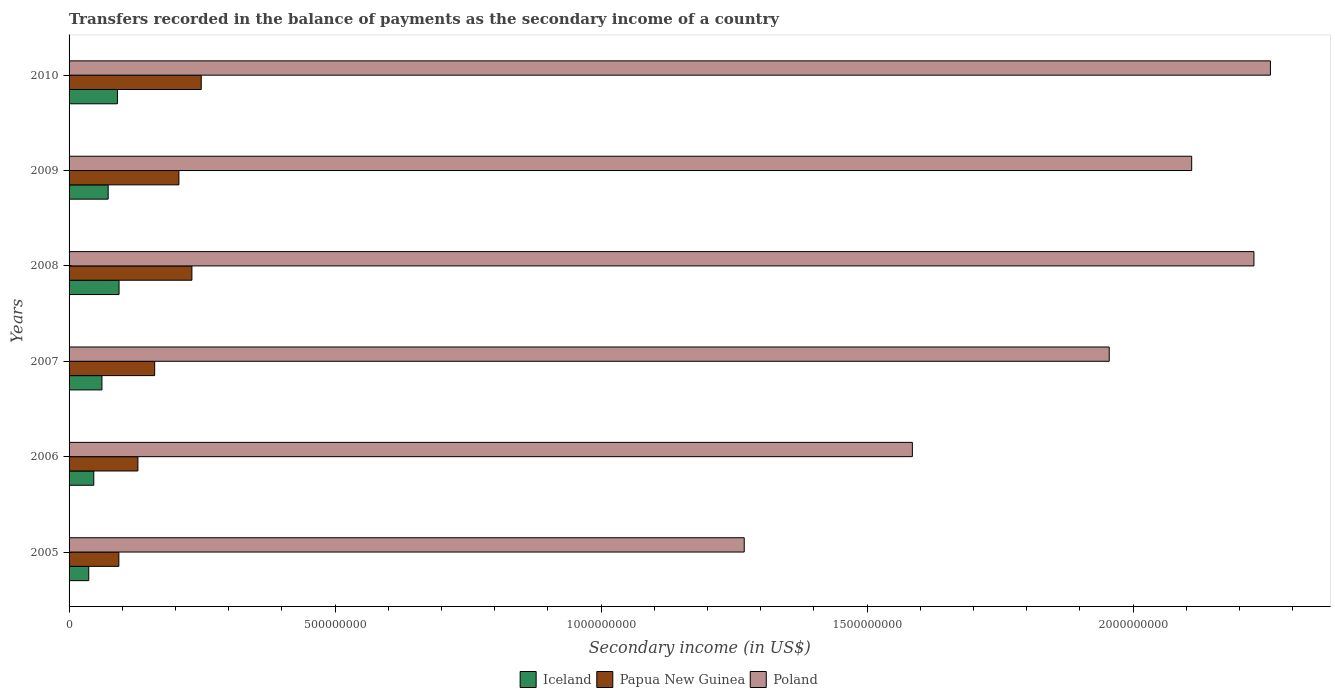How many different coloured bars are there?
Your answer should be compact. 3. How many groups of bars are there?
Provide a short and direct response. 6. Are the number of bars on each tick of the Y-axis equal?
Provide a short and direct response. Yes. How many bars are there on the 4th tick from the top?
Your response must be concise. 3. How many bars are there on the 3rd tick from the bottom?
Your answer should be very brief. 3. What is the label of the 4th group of bars from the top?
Provide a short and direct response. 2007. In how many cases, is the number of bars for a given year not equal to the number of legend labels?
Give a very brief answer. 0. What is the secondary income of in Papua New Guinea in 2010?
Keep it short and to the point. 2.48e+08. Across all years, what is the maximum secondary income of in Poland?
Your answer should be compact. 2.26e+09. Across all years, what is the minimum secondary income of in Poland?
Your response must be concise. 1.27e+09. In which year was the secondary income of in Poland maximum?
Provide a short and direct response. 2010. What is the total secondary income of in Poland in the graph?
Make the answer very short. 1.14e+1. What is the difference between the secondary income of in Papua New Guinea in 2008 and that in 2009?
Your response must be concise. 2.44e+07. What is the difference between the secondary income of in Papua New Guinea in 2009 and the secondary income of in Poland in 2007?
Your response must be concise. -1.75e+09. What is the average secondary income of in Poland per year?
Provide a short and direct response. 1.90e+09. In the year 2008, what is the difference between the secondary income of in Papua New Guinea and secondary income of in Poland?
Your answer should be very brief. -2.00e+09. In how many years, is the secondary income of in Poland greater than 1300000000 US$?
Your response must be concise. 5. What is the ratio of the secondary income of in Iceland in 2006 to that in 2008?
Offer a very short reply. 0.49. What is the difference between the highest and the second highest secondary income of in Iceland?
Offer a very short reply. 3.00e+06. What is the difference between the highest and the lowest secondary income of in Papua New Guinea?
Provide a succinct answer. 1.55e+08. Is the sum of the secondary income of in Papua New Guinea in 2005 and 2010 greater than the maximum secondary income of in Poland across all years?
Offer a very short reply. No. What does the 2nd bar from the top in 2007 represents?
Keep it short and to the point. Papua New Guinea. What does the 2nd bar from the bottom in 2009 represents?
Give a very brief answer. Papua New Guinea. Are all the bars in the graph horizontal?
Offer a terse response. Yes. How many years are there in the graph?
Provide a succinct answer. 6. Are the values on the major ticks of X-axis written in scientific E-notation?
Your answer should be compact. No. Does the graph contain grids?
Your answer should be very brief. No. What is the title of the graph?
Your answer should be very brief. Transfers recorded in the balance of payments as the secondary income of a country. Does "St. Vincent and the Grenadines" appear as one of the legend labels in the graph?
Provide a short and direct response. No. What is the label or title of the X-axis?
Offer a terse response. Secondary income (in US$). What is the Secondary income (in US$) in Iceland in 2005?
Your answer should be very brief. 3.70e+07. What is the Secondary income (in US$) in Papua New Guinea in 2005?
Ensure brevity in your answer.  9.36e+07. What is the Secondary income (in US$) of Poland in 2005?
Provide a succinct answer. 1.27e+09. What is the Secondary income (in US$) of Iceland in 2006?
Keep it short and to the point. 4.65e+07. What is the Secondary income (in US$) in Papua New Guinea in 2006?
Your response must be concise. 1.29e+08. What is the Secondary income (in US$) in Poland in 2006?
Ensure brevity in your answer.  1.58e+09. What is the Secondary income (in US$) in Iceland in 2007?
Provide a succinct answer. 6.18e+07. What is the Secondary income (in US$) of Papua New Guinea in 2007?
Your answer should be very brief. 1.61e+08. What is the Secondary income (in US$) in Poland in 2007?
Your answer should be very brief. 1.96e+09. What is the Secondary income (in US$) of Iceland in 2008?
Offer a terse response. 9.39e+07. What is the Secondary income (in US$) of Papua New Guinea in 2008?
Your response must be concise. 2.31e+08. What is the Secondary income (in US$) in Poland in 2008?
Your response must be concise. 2.23e+09. What is the Secondary income (in US$) in Iceland in 2009?
Ensure brevity in your answer.  7.35e+07. What is the Secondary income (in US$) of Papua New Guinea in 2009?
Offer a very short reply. 2.06e+08. What is the Secondary income (in US$) of Poland in 2009?
Offer a terse response. 2.11e+09. What is the Secondary income (in US$) of Iceland in 2010?
Ensure brevity in your answer.  9.09e+07. What is the Secondary income (in US$) in Papua New Guinea in 2010?
Give a very brief answer. 2.48e+08. What is the Secondary income (in US$) of Poland in 2010?
Give a very brief answer. 2.26e+09. Across all years, what is the maximum Secondary income (in US$) of Iceland?
Your answer should be compact. 9.39e+07. Across all years, what is the maximum Secondary income (in US$) in Papua New Guinea?
Provide a short and direct response. 2.48e+08. Across all years, what is the maximum Secondary income (in US$) in Poland?
Your answer should be very brief. 2.26e+09. Across all years, what is the minimum Secondary income (in US$) in Iceland?
Offer a terse response. 3.70e+07. Across all years, what is the minimum Secondary income (in US$) in Papua New Guinea?
Your response must be concise. 9.36e+07. Across all years, what is the minimum Secondary income (in US$) of Poland?
Offer a very short reply. 1.27e+09. What is the total Secondary income (in US$) in Iceland in the graph?
Offer a terse response. 4.04e+08. What is the total Secondary income (in US$) of Papua New Guinea in the graph?
Offer a very short reply. 1.07e+09. What is the total Secondary income (in US$) of Poland in the graph?
Your answer should be very brief. 1.14e+1. What is the difference between the Secondary income (in US$) of Iceland in 2005 and that in 2006?
Provide a short and direct response. -9.48e+06. What is the difference between the Secondary income (in US$) of Papua New Guinea in 2005 and that in 2006?
Offer a very short reply. -3.58e+07. What is the difference between the Secondary income (in US$) in Poland in 2005 and that in 2006?
Provide a short and direct response. -3.16e+08. What is the difference between the Secondary income (in US$) in Iceland in 2005 and that in 2007?
Ensure brevity in your answer.  -2.48e+07. What is the difference between the Secondary income (in US$) in Papua New Guinea in 2005 and that in 2007?
Your response must be concise. -6.73e+07. What is the difference between the Secondary income (in US$) in Poland in 2005 and that in 2007?
Ensure brevity in your answer.  -6.86e+08. What is the difference between the Secondary income (in US$) of Iceland in 2005 and that in 2008?
Ensure brevity in your answer.  -5.69e+07. What is the difference between the Secondary income (in US$) in Papua New Guinea in 2005 and that in 2008?
Your response must be concise. -1.37e+08. What is the difference between the Secondary income (in US$) of Poland in 2005 and that in 2008?
Provide a succinct answer. -9.58e+08. What is the difference between the Secondary income (in US$) of Iceland in 2005 and that in 2009?
Your response must be concise. -3.65e+07. What is the difference between the Secondary income (in US$) in Papua New Guinea in 2005 and that in 2009?
Keep it short and to the point. -1.13e+08. What is the difference between the Secondary income (in US$) of Poland in 2005 and that in 2009?
Offer a very short reply. -8.41e+08. What is the difference between the Secondary income (in US$) in Iceland in 2005 and that in 2010?
Keep it short and to the point. -5.39e+07. What is the difference between the Secondary income (in US$) of Papua New Guinea in 2005 and that in 2010?
Provide a succinct answer. -1.55e+08. What is the difference between the Secondary income (in US$) of Poland in 2005 and that in 2010?
Offer a very short reply. -9.89e+08. What is the difference between the Secondary income (in US$) of Iceland in 2006 and that in 2007?
Offer a terse response. -1.53e+07. What is the difference between the Secondary income (in US$) of Papua New Guinea in 2006 and that in 2007?
Your answer should be very brief. -3.15e+07. What is the difference between the Secondary income (in US$) of Poland in 2006 and that in 2007?
Your response must be concise. -3.70e+08. What is the difference between the Secondary income (in US$) of Iceland in 2006 and that in 2008?
Provide a succinct answer. -4.75e+07. What is the difference between the Secondary income (in US$) of Papua New Guinea in 2006 and that in 2008?
Your answer should be compact. -1.01e+08. What is the difference between the Secondary income (in US$) in Poland in 2006 and that in 2008?
Offer a very short reply. -6.42e+08. What is the difference between the Secondary income (in US$) of Iceland in 2006 and that in 2009?
Offer a terse response. -2.70e+07. What is the difference between the Secondary income (in US$) in Papua New Guinea in 2006 and that in 2009?
Your response must be concise. -7.71e+07. What is the difference between the Secondary income (in US$) of Poland in 2006 and that in 2009?
Ensure brevity in your answer.  -5.25e+08. What is the difference between the Secondary income (in US$) in Iceland in 2006 and that in 2010?
Ensure brevity in your answer.  -4.45e+07. What is the difference between the Secondary income (in US$) in Papua New Guinea in 2006 and that in 2010?
Ensure brevity in your answer.  -1.19e+08. What is the difference between the Secondary income (in US$) in Poland in 2006 and that in 2010?
Provide a short and direct response. -6.73e+08. What is the difference between the Secondary income (in US$) in Iceland in 2007 and that in 2008?
Ensure brevity in your answer.  -3.22e+07. What is the difference between the Secondary income (in US$) of Papua New Guinea in 2007 and that in 2008?
Offer a terse response. -7.00e+07. What is the difference between the Secondary income (in US$) of Poland in 2007 and that in 2008?
Your answer should be compact. -2.72e+08. What is the difference between the Secondary income (in US$) of Iceland in 2007 and that in 2009?
Provide a short and direct response. -1.17e+07. What is the difference between the Secondary income (in US$) in Papua New Guinea in 2007 and that in 2009?
Make the answer very short. -4.56e+07. What is the difference between the Secondary income (in US$) of Poland in 2007 and that in 2009?
Provide a short and direct response. -1.55e+08. What is the difference between the Secondary income (in US$) of Iceland in 2007 and that in 2010?
Offer a very short reply. -2.91e+07. What is the difference between the Secondary income (in US$) of Papua New Guinea in 2007 and that in 2010?
Offer a very short reply. -8.75e+07. What is the difference between the Secondary income (in US$) of Poland in 2007 and that in 2010?
Ensure brevity in your answer.  -3.03e+08. What is the difference between the Secondary income (in US$) in Iceland in 2008 and that in 2009?
Keep it short and to the point. 2.04e+07. What is the difference between the Secondary income (in US$) in Papua New Guinea in 2008 and that in 2009?
Ensure brevity in your answer.  2.44e+07. What is the difference between the Secondary income (in US$) of Poland in 2008 and that in 2009?
Your answer should be compact. 1.17e+08. What is the difference between the Secondary income (in US$) in Iceland in 2008 and that in 2010?
Ensure brevity in your answer.  3.00e+06. What is the difference between the Secondary income (in US$) of Papua New Guinea in 2008 and that in 2010?
Make the answer very short. -1.75e+07. What is the difference between the Secondary income (in US$) in Poland in 2008 and that in 2010?
Your response must be concise. -3.10e+07. What is the difference between the Secondary income (in US$) of Iceland in 2009 and that in 2010?
Make the answer very short. -1.74e+07. What is the difference between the Secondary income (in US$) in Papua New Guinea in 2009 and that in 2010?
Provide a short and direct response. -4.20e+07. What is the difference between the Secondary income (in US$) of Poland in 2009 and that in 2010?
Ensure brevity in your answer.  -1.48e+08. What is the difference between the Secondary income (in US$) of Iceland in 2005 and the Secondary income (in US$) of Papua New Guinea in 2006?
Your answer should be very brief. -9.24e+07. What is the difference between the Secondary income (in US$) in Iceland in 2005 and the Secondary income (in US$) in Poland in 2006?
Your answer should be compact. -1.55e+09. What is the difference between the Secondary income (in US$) of Papua New Guinea in 2005 and the Secondary income (in US$) of Poland in 2006?
Keep it short and to the point. -1.49e+09. What is the difference between the Secondary income (in US$) in Iceland in 2005 and the Secondary income (in US$) in Papua New Guinea in 2007?
Ensure brevity in your answer.  -1.24e+08. What is the difference between the Secondary income (in US$) in Iceland in 2005 and the Secondary income (in US$) in Poland in 2007?
Make the answer very short. -1.92e+09. What is the difference between the Secondary income (in US$) in Papua New Guinea in 2005 and the Secondary income (in US$) in Poland in 2007?
Give a very brief answer. -1.86e+09. What is the difference between the Secondary income (in US$) in Iceland in 2005 and the Secondary income (in US$) in Papua New Guinea in 2008?
Your answer should be very brief. -1.94e+08. What is the difference between the Secondary income (in US$) in Iceland in 2005 and the Secondary income (in US$) in Poland in 2008?
Ensure brevity in your answer.  -2.19e+09. What is the difference between the Secondary income (in US$) in Papua New Guinea in 2005 and the Secondary income (in US$) in Poland in 2008?
Keep it short and to the point. -2.13e+09. What is the difference between the Secondary income (in US$) of Iceland in 2005 and the Secondary income (in US$) of Papua New Guinea in 2009?
Your answer should be very brief. -1.69e+08. What is the difference between the Secondary income (in US$) in Iceland in 2005 and the Secondary income (in US$) in Poland in 2009?
Your response must be concise. -2.07e+09. What is the difference between the Secondary income (in US$) in Papua New Guinea in 2005 and the Secondary income (in US$) in Poland in 2009?
Provide a succinct answer. -2.02e+09. What is the difference between the Secondary income (in US$) of Iceland in 2005 and the Secondary income (in US$) of Papua New Guinea in 2010?
Give a very brief answer. -2.11e+08. What is the difference between the Secondary income (in US$) in Iceland in 2005 and the Secondary income (in US$) in Poland in 2010?
Give a very brief answer. -2.22e+09. What is the difference between the Secondary income (in US$) in Papua New Guinea in 2005 and the Secondary income (in US$) in Poland in 2010?
Your answer should be very brief. -2.16e+09. What is the difference between the Secondary income (in US$) in Iceland in 2006 and the Secondary income (in US$) in Papua New Guinea in 2007?
Make the answer very short. -1.14e+08. What is the difference between the Secondary income (in US$) in Iceland in 2006 and the Secondary income (in US$) in Poland in 2007?
Provide a short and direct response. -1.91e+09. What is the difference between the Secondary income (in US$) of Papua New Guinea in 2006 and the Secondary income (in US$) of Poland in 2007?
Your response must be concise. -1.83e+09. What is the difference between the Secondary income (in US$) of Iceland in 2006 and the Secondary income (in US$) of Papua New Guinea in 2008?
Ensure brevity in your answer.  -1.84e+08. What is the difference between the Secondary income (in US$) in Iceland in 2006 and the Secondary income (in US$) in Poland in 2008?
Your answer should be very brief. -2.18e+09. What is the difference between the Secondary income (in US$) in Papua New Guinea in 2006 and the Secondary income (in US$) in Poland in 2008?
Your answer should be very brief. -2.10e+09. What is the difference between the Secondary income (in US$) in Iceland in 2006 and the Secondary income (in US$) in Papua New Guinea in 2009?
Provide a short and direct response. -1.60e+08. What is the difference between the Secondary income (in US$) of Iceland in 2006 and the Secondary income (in US$) of Poland in 2009?
Provide a short and direct response. -2.06e+09. What is the difference between the Secondary income (in US$) of Papua New Guinea in 2006 and the Secondary income (in US$) of Poland in 2009?
Offer a terse response. -1.98e+09. What is the difference between the Secondary income (in US$) in Iceland in 2006 and the Secondary income (in US$) in Papua New Guinea in 2010?
Provide a short and direct response. -2.02e+08. What is the difference between the Secondary income (in US$) in Iceland in 2006 and the Secondary income (in US$) in Poland in 2010?
Offer a very short reply. -2.21e+09. What is the difference between the Secondary income (in US$) of Papua New Guinea in 2006 and the Secondary income (in US$) of Poland in 2010?
Offer a very short reply. -2.13e+09. What is the difference between the Secondary income (in US$) of Iceland in 2007 and the Secondary income (in US$) of Papua New Guinea in 2008?
Make the answer very short. -1.69e+08. What is the difference between the Secondary income (in US$) in Iceland in 2007 and the Secondary income (in US$) in Poland in 2008?
Offer a very short reply. -2.17e+09. What is the difference between the Secondary income (in US$) in Papua New Guinea in 2007 and the Secondary income (in US$) in Poland in 2008?
Make the answer very short. -2.07e+09. What is the difference between the Secondary income (in US$) of Iceland in 2007 and the Secondary income (in US$) of Papua New Guinea in 2009?
Keep it short and to the point. -1.45e+08. What is the difference between the Secondary income (in US$) in Iceland in 2007 and the Secondary income (in US$) in Poland in 2009?
Your answer should be compact. -2.05e+09. What is the difference between the Secondary income (in US$) in Papua New Guinea in 2007 and the Secondary income (in US$) in Poland in 2009?
Provide a succinct answer. -1.95e+09. What is the difference between the Secondary income (in US$) of Iceland in 2007 and the Secondary income (in US$) of Papua New Guinea in 2010?
Ensure brevity in your answer.  -1.87e+08. What is the difference between the Secondary income (in US$) of Iceland in 2007 and the Secondary income (in US$) of Poland in 2010?
Provide a succinct answer. -2.20e+09. What is the difference between the Secondary income (in US$) of Papua New Guinea in 2007 and the Secondary income (in US$) of Poland in 2010?
Offer a very short reply. -2.10e+09. What is the difference between the Secondary income (in US$) in Iceland in 2008 and the Secondary income (in US$) in Papua New Guinea in 2009?
Make the answer very short. -1.13e+08. What is the difference between the Secondary income (in US$) of Iceland in 2008 and the Secondary income (in US$) of Poland in 2009?
Offer a very short reply. -2.02e+09. What is the difference between the Secondary income (in US$) in Papua New Guinea in 2008 and the Secondary income (in US$) in Poland in 2009?
Provide a short and direct response. -1.88e+09. What is the difference between the Secondary income (in US$) of Iceland in 2008 and the Secondary income (in US$) of Papua New Guinea in 2010?
Your response must be concise. -1.54e+08. What is the difference between the Secondary income (in US$) of Iceland in 2008 and the Secondary income (in US$) of Poland in 2010?
Your answer should be very brief. -2.16e+09. What is the difference between the Secondary income (in US$) in Papua New Guinea in 2008 and the Secondary income (in US$) in Poland in 2010?
Make the answer very short. -2.03e+09. What is the difference between the Secondary income (in US$) of Iceland in 2009 and the Secondary income (in US$) of Papua New Guinea in 2010?
Provide a short and direct response. -1.75e+08. What is the difference between the Secondary income (in US$) of Iceland in 2009 and the Secondary income (in US$) of Poland in 2010?
Ensure brevity in your answer.  -2.18e+09. What is the difference between the Secondary income (in US$) in Papua New Guinea in 2009 and the Secondary income (in US$) in Poland in 2010?
Offer a terse response. -2.05e+09. What is the average Secondary income (in US$) in Iceland per year?
Your answer should be very brief. 6.73e+07. What is the average Secondary income (in US$) of Papua New Guinea per year?
Your response must be concise. 1.78e+08. What is the average Secondary income (in US$) in Poland per year?
Provide a short and direct response. 1.90e+09. In the year 2005, what is the difference between the Secondary income (in US$) in Iceland and Secondary income (in US$) in Papua New Guinea?
Make the answer very short. -5.66e+07. In the year 2005, what is the difference between the Secondary income (in US$) of Iceland and Secondary income (in US$) of Poland?
Ensure brevity in your answer.  -1.23e+09. In the year 2005, what is the difference between the Secondary income (in US$) of Papua New Guinea and Secondary income (in US$) of Poland?
Offer a terse response. -1.18e+09. In the year 2006, what is the difference between the Secondary income (in US$) in Iceland and Secondary income (in US$) in Papua New Guinea?
Keep it short and to the point. -8.29e+07. In the year 2006, what is the difference between the Secondary income (in US$) in Iceland and Secondary income (in US$) in Poland?
Give a very brief answer. -1.54e+09. In the year 2006, what is the difference between the Secondary income (in US$) in Papua New Guinea and Secondary income (in US$) in Poland?
Ensure brevity in your answer.  -1.46e+09. In the year 2007, what is the difference between the Secondary income (in US$) of Iceland and Secondary income (in US$) of Papua New Guinea?
Provide a succinct answer. -9.91e+07. In the year 2007, what is the difference between the Secondary income (in US$) of Iceland and Secondary income (in US$) of Poland?
Offer a terse response. -1.89e+09. In the year 2007, what is the difference between the Secondary income (in US$) of Papua New Guinea and Secondary income (in US$) of Poland?
Give a very brief answer. -1.79e+09. In the year 2008, what is the difference between the Secondary income (in US$) of Iceland and Secondary income (in US$) of Papua New Guinea?
Make the answer very short. -1.37e+08. In the year 2008, what is the difference between the Secondary income (in US$) of Iceland and Secondary income (in US$) of Poland?
Provide a succinct answer. -2.13e+09. In the year 2008, what is the difference between the Secondary income (in US$) in Papua New Guinea and Secondary income (in US$) in Poland?
Offer a terse response. -2.00e+09. In the year 2009, what is the difference between the Secondary income (in US$) in Iceland and Secondary income (in US$) in Papua New Guinea?
Give a very brief answer. -1.33e+08. In the year 2009, what is the difference between the Secondary income (in US$) in Iceland and Secondary income (in US$) in Poland?
Your answer should be very brief. -2.04e+09. In the year 2009, what is the difference between the Secondary income (in US$) of Papua New Guinea and Secondary income (in US$) of Poland?
Provide a succinct answer. -1.90e+09. In the year 2010, what is the difference between the Secondary income (in US$) in Iceland and Secondary income (in US$) in Papua New Guinea?
Your answer should be compact. -1.57e+08. In the year 2010, what is the difference between the Secondary income (in US$) of Iceland and Secondary income (in US$) of Poland?
Provide a succinct answer. -2.17e+09. In the year 2010, what is the difference between the Secondary income (in US$) in Papua New Guinea and Secondary income (in US$) in Poland?
Your answer should be very brief. -2.01e+09. What is the ratio of the Secondary income (in US$) in Iceland in 2005 to that in 2006?
Provide a succinct answer. 0.8. What is the ratio of the Secondary income (in US$) in Papua New Guinea in 2005 to that in 2006?
Give a very brief answer. 0.72. What is the ratio of the Secondary income (in US$) in Poland in 2005 to that in 2006?
Offer a very short reply. 0.8. What is the ratio of the Secondary income (in US$) of Iceland in 2005 to that in 2007?
Offer a terse response. 0.6. What is the ratio of the Secondary income (in US$) in Papua New Guinea in 2005 to that in 2007?
Offer a terse response. 0.58. What is the ratio of the Secondary income (in US$) in Poland in 2005 to that in 2007?
Ensure brevity in your answer.  0.65. What is the ratio of the Secondary income (in US$) of Iceland in 2005 to that in 2008?
Ensure brevity in your answer.  0.39. What is the ratio of the Secondary income (in US$) of Papua New Guinea in 2005 to that in 2008?
Give a very brief answer. 0.41. What is the ratio of the Secondary income (in US$) in Poland in 2005 to that in 2008?
Your answer should be very brief. 0.57. What is the ratio of the Secondary income (in US$) of Iceland in 2005 to that in 2009?
Provide a short and direct response. 0.5. What is the ratio of the Secondary income (in US$) of Papua New Guinea in 2005 to that in 2009?
Offer a very short reply. 0.45. What is the ratio of the Secondary income (in US$) in Poland in 2005 to that in 2009?
Your answer should be compact. 0.6. What is the ratio of the Secondary income (in US$) of Iceland in 2005 to that in 2010?
Offer a terse response. 0.41. What is the ratio of the Secondary income (in US$) of Papua New Guinea in 2005 to that in 2010?
Provide a short and direct response. 0.38. What is the ratio of the Secondary income (in US$) of Poland in 2005 to that in 2010?
Offer a very short reply. 0.56. What is the ratio of the Secondary income (in US$) in Iceland in 2006 to that in 2007?
Your response must be concise. 0.75. What is the ratio of the Secondary income (in US$) of Papua New Guinea in 2006 to that in 2007?
Provide a succinct answer. 0.8. What is the ratio of the Secondary income (in US$) of Poland in 2006 to that in 2007?
Provide a short and direct response. 0.81. What is the ratio of the Secondary income (in US$) in Iceland in 2006 to that in 2008?
Offer a terse response. 0.49. What is the ratio of the Secondary income (in US$) of Papua New Guinea in 2006 to that in 2008?
Your answer should be very brief. 0.56. What is the ratio of the Secondary income (in US$) in Poland in 2006 to that in 2008?
Offer a terse response. 0.71. What is the ratio of the Secondary income (in US$) of Iceland in 2006 to that in 2009?
Provide a succinct answer. 0.63. What is the ratio of the Secondary income (in US$) in Papua New Guinea in 2006 to that in 2009?
Keep it short and to the point. 0.63. What is the ratio of the Secondary income (in US$) in Poland in 2006 to that in 2009?
Keep it short and to the point. 0.75. What is the ratio of the Secondary income (in US$) of Iceland in 2006 to that in 2010?
Ensure brevity in your answer.  0.51. What is the ratio of the Secondary income (in US$) in Papua New Guinea in 2006 to that in 2010?
Your answer should be compact. 0.52. What is the ratio of the Secondary income (in US$) in Poland in 2006 to that in 2010?
Your response must be concise. 0.7. What is the ratio of the Secondary income (in US$) in Iceland in 2007 to that in 2008?
Make the answer very short. 0.66. What is the ratio of the Secondary income (in US$) of Papua New Guinea in 2007 to that in 2008?
Offer a very short reply. 0.7. What is the ratio of the Secondary income (in US$) in Poland in 2007 to that in 2008?
Your answer should be compact. 0.88. What is the ratio of the Secondary income (in US$) in Iceland in 2007 to that in 2009?
Your answer should be compact. 0.84. What is the ratio of the Secondary income (in US$) in Papua New Guinea in 2007 to that in 2009?
Offer a very short reply. 0.78. What is the ratio of the Secondary income (in US$) in Poland in 2007 to that in 2009?
Your response must be concise. 0.93. What is the ratio of the Secondary income (in US$) in Iceland in 2007 to that in 2010?
Make the answer very short. 0.68. What is the ratio of the Secondary income (in US$) of Papua New Guinea in 2007 to that in 2010?
Keep it short and to the point. 0.65. What is the ratio of the Secondary income (in US$) in Poland in 2007 to that in 2010?
Provide a short and direct response. 0.87. What is the ratio of the Secondary income (in US$) of Iceland in 2008 to that in 2009?
Provide a succinct answer. 1.28. What is the ratio of the Secondary income (in US$) in Papua New Guinea in 2008 to that in 2009?
Provide a short and direct response. 1.12. What is the ratio of the Secondary income (in US$) of Poland in 2008 to that in 2009?
Your answer should be compact. 1.06. What is the ratio of the Secondary income (in US$) in Iceland in 2008 to that in 2010?
Your answer should be compact. 1.03. What is the ratio of the Secondary income (in US$) of Papua New Guinea in 2008 to that in 2010?
Provide a short and direct response. 0.93. What is the ratio of the Secondary income (in US$) in Poland in 2008 to that in 2010?
Offer a very short reply. 0.99. What is the ratio of the Secondary income (in US$) of Iceland in 2009 to that in 2010?
Ensure brevity in your answer.  0.81. What is the ratio of the Secondary income (in US$) in Papua New Guinea in 2009 to that in 2010?
Your answer should be compact. 0.83. What is the ratio of the Secondary income (in US$) of Poland in 2009 to that in 2010?
Make the answer very short. 0.93. What is the difference between the highest and the second highest Secondary income (in US$) of Iceland?
Provide a short and direct response. 3.00e+06. What is the difference between the highest and the second highest Secondary income (in US$) in Papua New Guinea?
Ensure brevity in your answer.  1.75e+07. What is the difference between the highest and the second highest Secondary income (in US$) in Poland?
Make the answer very short. 3.10e+07. What is the difference between the highest and the lowest Secondary income (in US$) in Iceland?
Make the answer very short. 5.69e+07. What is the difference between the highest and the lowest Secondary income (in US$) of Papua New Guinea?
Your response must be concise. 1.55e+08. What is the difference between the highest and the lowest Secondary income (in US$) in Poland?
Offer a terse response. 9.89e+08. 